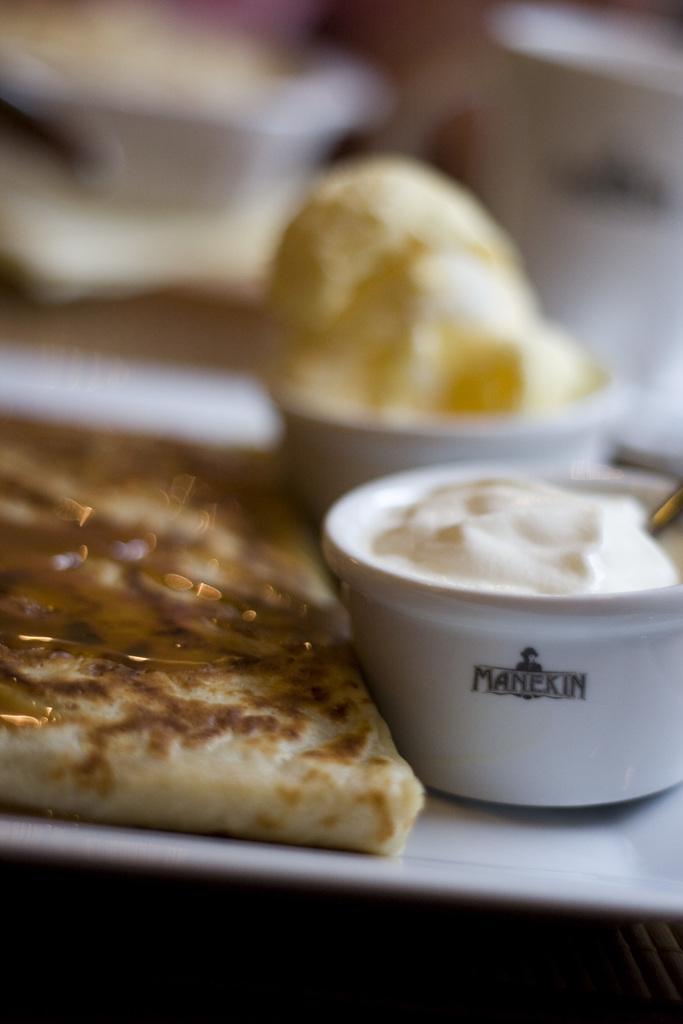How would you summarize this image in a sentence or two? In this picture there is a tray in the center of the image, in which there is bread and other food items in the bowls. 